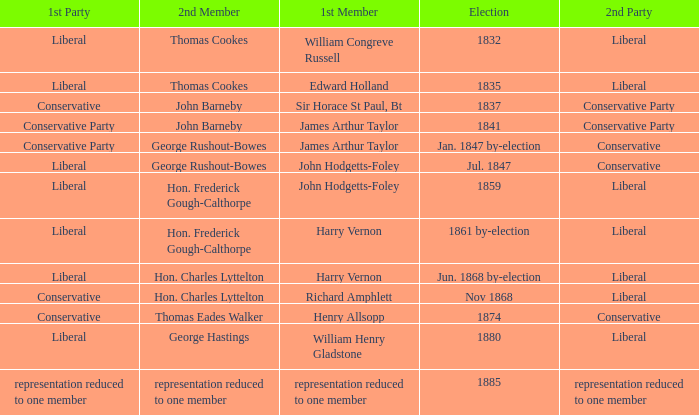Could you help me parse every detail presented in this table? {'header': ['1st Party', '2nd Member', '1st Member', 'Election', '2nd Party'], 'rows': [['Liberal', 'Thomas Cookes', 'William Congreve Russell', '1832', 'Liberal'], ['Liberal', 'Thomas Cookes', 'Edward Holland', '1835', 'Liberal'], ['Conservative', 'John Barneby', 'Sir Horace St Paul, Bt', '1837', 'Conservative Party'], ['Conservative Party', 'John Barneby', 'James Arthur Taylor', '1841', 'Conservative Party'], ['Conservative Party', 'George Rushout-Bowes', 'James Arthur Taylor', 'Jan. 1847 by-election', 'Conservative'], ['Liberal', 'George Rushout-Bowes', 'John Hodgetts-Foley', 'Jul. 1847', 'Conservative'], ['Liberal', 'Hon. Frederick Gough-Calthorpe', 'John Hodgetts-Foley', '1859', 'Liberal'], ['Liberal', 'Hon. Frederick Gough-Calthorpe', 'Harry Vernon', '1861 by-election', 'Liberal'], ['Liberal', 'Hon. Charles Lyttelton', 'Harry Vernon', 'Jun. 1868 by-election', 'Liberal'], ['Conservative', 'Hon. Charles Lyttelton', 'Richard Amphlett', 'Nov 1868', 'Liberal'], ['Conservative', 'Thomas Eades Walker', 'Henry Allsopp', '1874', 'Conservative'], ['Liberal', 'George Hastings', 'William Henry Gladstone', '1880', 'Liberal'], ['representation reduced to one member', 'representation reduced to one member', 'representation reduced to one member', '1885', 'representation reduced to one member']]} What was the 1st Party when the 1st Member was William Congreve Russell? Liberal. 